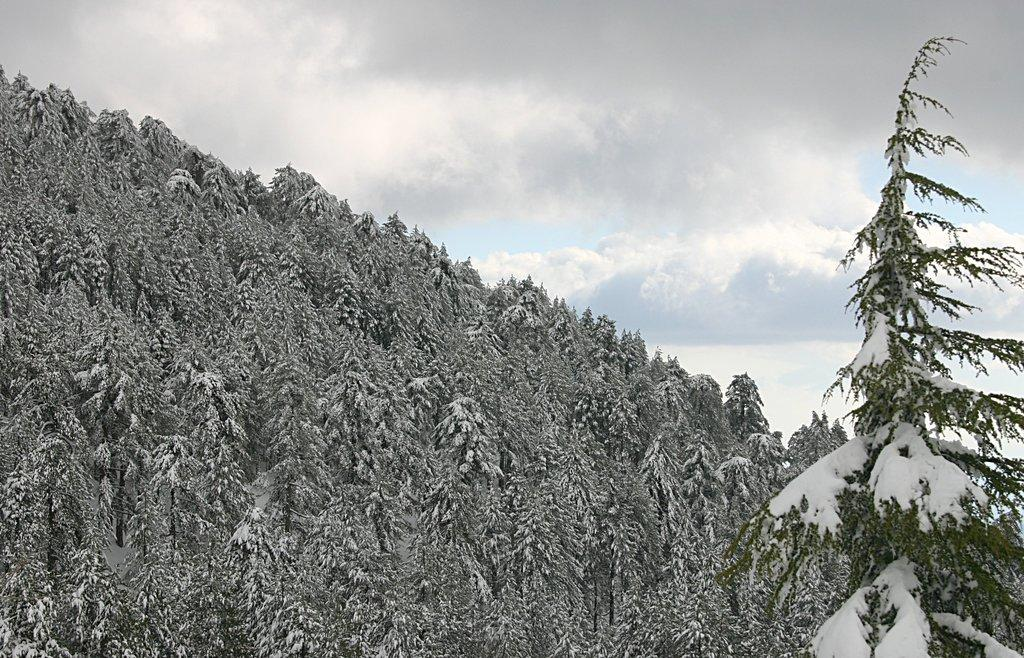What type of vegetation can be seen in the image? There are trees in the image. What is covering the trees in the image? There is snow on the trees. What can be seen in the background of the image? There is a sky visible in the background of the image. What is the condition of the sky in the image? There are clouds in the sky. Where is the ticket located in the image? There is no ticket present in the image. What type of pot is visible in the image? There is no pot present in the image. 